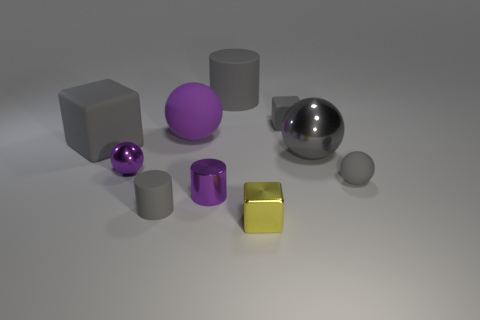Subtract all blocks. How many objects are left? 7 Subtract all gray spheres. How many blue cylinders are left? 0 Subtract all tiny metallic blocks. Subtract all tiny yellow metallic objects. How many objects are left? 8 Add 7 big gray rubber objects. How many big gray rubber objects are left? 9 Add 9 tiny brown metallic cylinders. How many tiny brown metallic cylinders exist? 9 Subtract all purple cylinders. How many cylinders are left? 2 Subtract all small gray cylinders. How many cylinders are left? 2 Subtract 0 purple cubes. How many objects are left? 10 Subtract 1 spheres. How many spheres are left? 3 Subtract all brown blocks. Subtract all purple cylinders. How many blocks are left? 3 